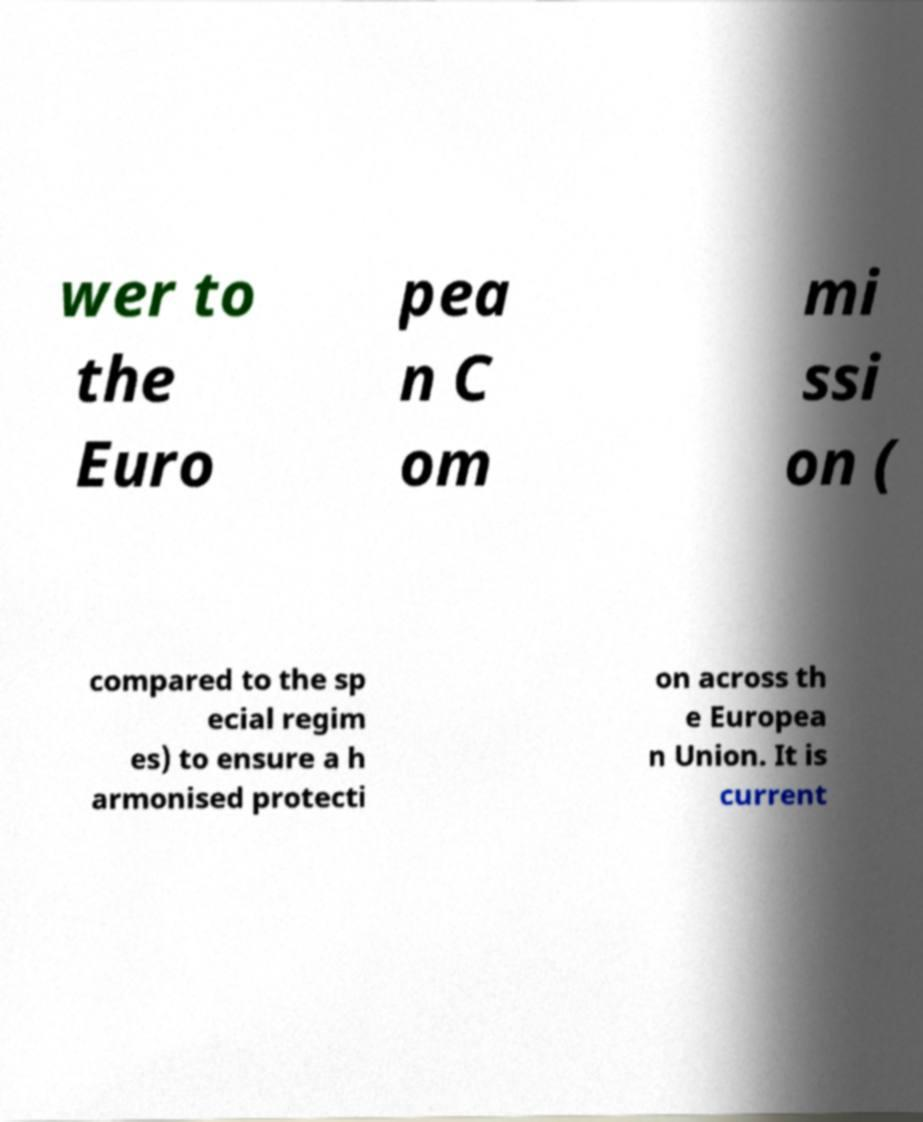Could you extract and type out the text from this image? wer to the Euro pea n C om mi ssi on ( compared to the sp ecial regim es) to ensure a h armonised protecti on across th e Europea n Union. It is current 